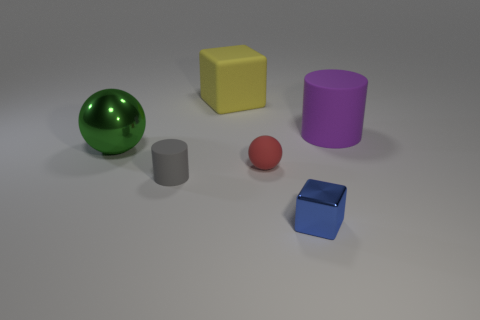Add 1 matte cylinders. How many objects exist? 7 Subtract all balls. How many objects are left? 4 Subtract 0 red blocks. How many objects are left? 6 Subtract all big cubes. Subtract all small red matte balls. How many objects are left? 4 Add 3 big green objects. How many big green objects are left? 4 Add 4 large blue matte spheres. How many large blue matte spheres exist? 4 